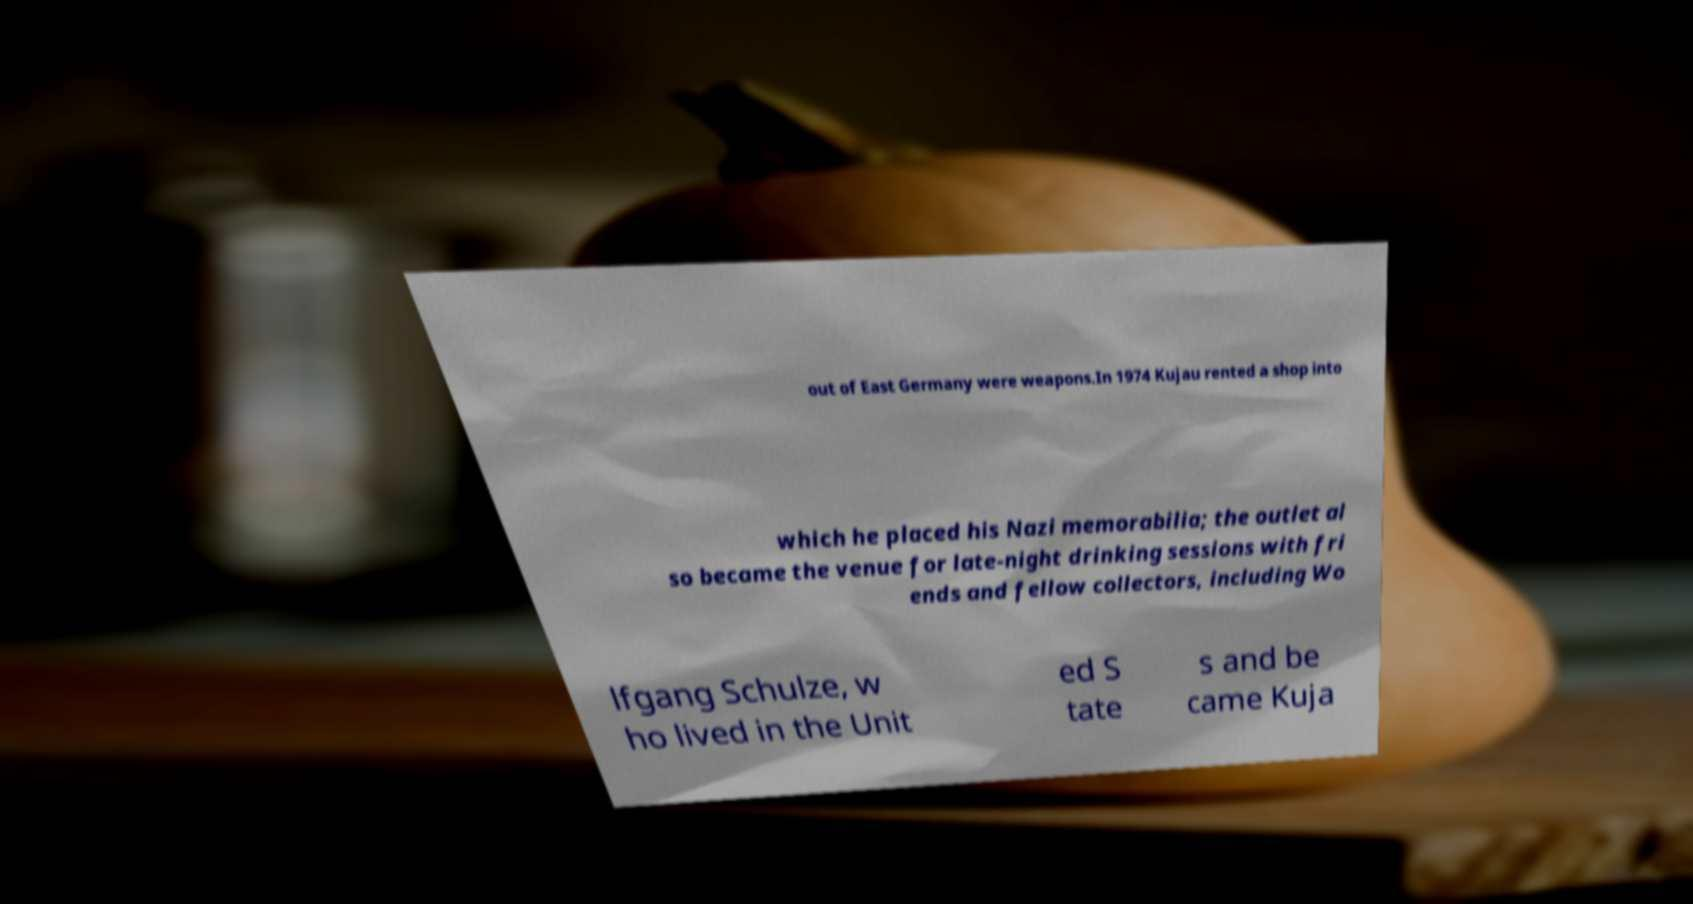There's text embedded in this image that I need extracted. Can you transcribe it verbatim? out of East Germany were weapons.In 1974 Kujau rented a shop into which he placed his Nazi memorabilia; the outlet al so became the venue for late-night drinking sessions with fri ends and fellow collectors, including Wo lfgang Schulze, w ho lived in the Unit ed S tate s and be came Kuja 